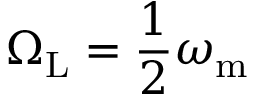<formula> <loc_0><loc_0><loc_500><loc_500>\Omega _ { L } = \frac { 1 } { 2 } \omega _ { m }</formula> 